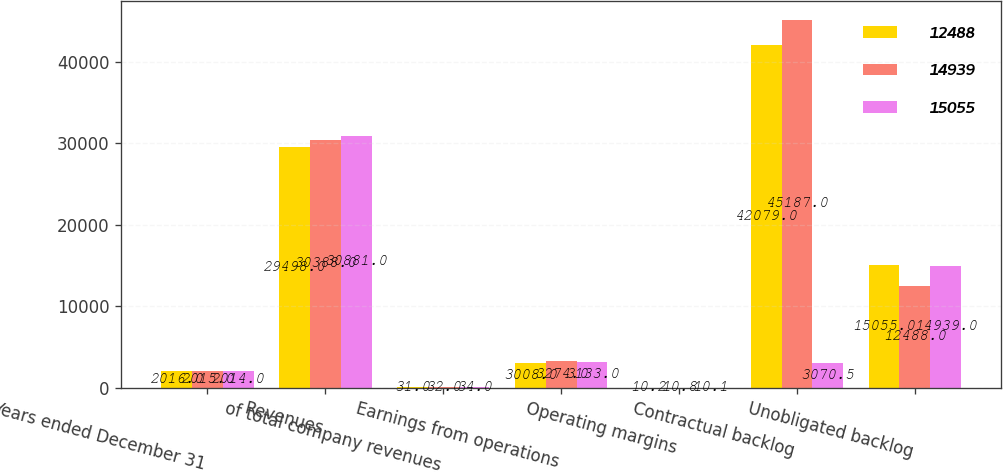Convert chart. <chart><loc_0><loc_0><loc_500><loc_500><stacked_bar_chart><ecel><fcel>Years ended December 31<fcel>Revenues<fcel>of total company revenues<fcel>Earnings from operations<fcel>Operating margins<fcel>Contractual backlog<fcel>Unobligated backlog<nl><fcel>12488<fcel>2016<fcel>29498<fcel>31<fcel>3008<fcel>10.2<fcel>42079<fcel>15055<nl><fcel>14939<fcel>2015<fcel>30388<fcel>32<fcel>3274<fcel>10.8<fcel>45187<fcel>12488<nl><fcel>15055<fcel>2014<fcel>30881<fcel>34<fcel>3133<fcel>10.1<fcel>3070.5<fcel>14939<nl></chart> 